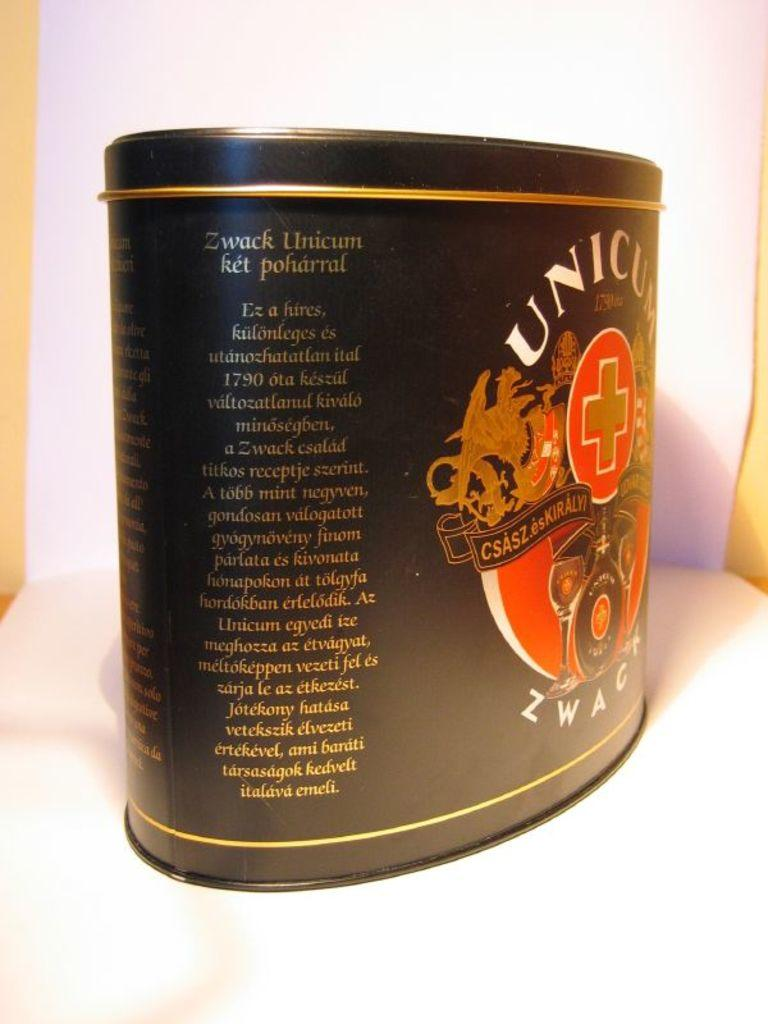<image>
Offer a succinct explanation of the picture presented. Zwack Unicum is the name-brand printed on a black tin. 